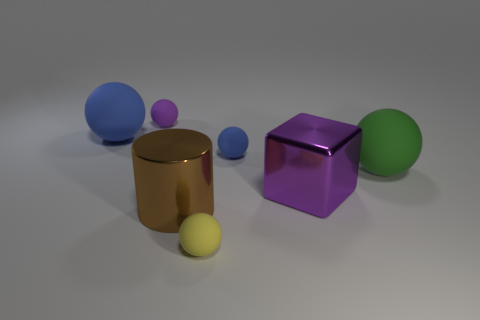Is the number of yellow rubber spheres that are on the right side of the large purple object less than the number of big blue rubber balls?
Your response must be concise. Yes. What number of blue objects are the same size as the purple rubber object?
Provide a succinct answer. 1. What shape is the rubber object that is the same color as the big cube?
Make the answer very short. Sphere. The blue matte thing that is in front of the big rubber thing that is to the left of the large matte object on the right side of the metallic cube is what shape?
Ensure brevity in your answer.  Sphere. There is a tiny ball in front of the metal block; what color is it?
Your answer should be compact. Yellow. What number of objects are small rubber spheres that are in front of the large purple metallic cube or objects in front of the small blue object?
Give a very brief answer. 4. How many blue matte objects have the same shape as the tiny purple thing?
Your answer should be compact. 2. The shiny cylinder that is the same size as the purple block is what color?
Provide a succinct answer. Brown. There is a large metal object left of the tiny rubber thing that is in front of the thing that is to the right of the purple metal cube; what is its color?
Make the answer very short. Brown. Is the size of the purple metallic block the same as the blue rubber sphere that is on the left side of the tiny yellow object?
Provide a succinct answer. Yes. 